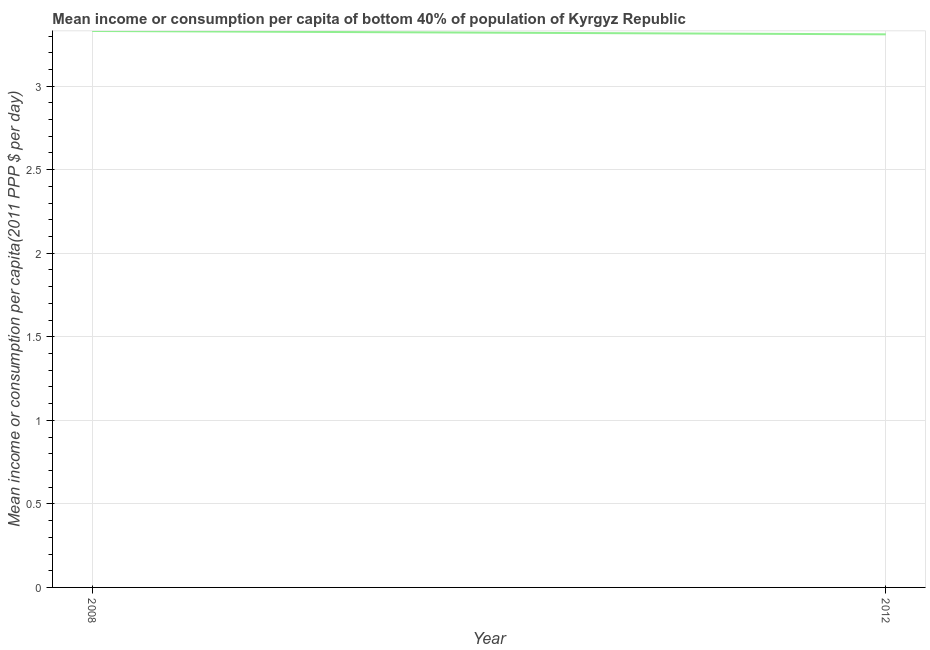What is the mean income or consumption in 2012?
Your answer should be very brief. 3.31. Across all years, what is the maximum mean income or consumption?
Give a very brief answer. 3.33. Across all years, what is the minimum mean income or consumption?
Offer a terse response. 3.31. In which year was the mean income or consumption maximum?
Provide a succinct answer. 2008. What is the sum of the mean income or consumption?
Keep it short and to the point. 6.64. What is the difference between the mean income or consumption in 2008 and 2012?
Give a very brief answer. 0.02. What is the average mean income or consumption per year?
Your answer should be very brief. 3.32. What is the median mean income or consumption?
Provide a succinct answer. 3.32. In how many years, is the mean income or consumption greater than 2.1 $?
Keep it short and to the point. 2. What is the ratio of the mean income or consumption in 2008 to that in 2012?
Keep it short and to the point. 1.01. Is the mean income or consumption in 2008 less than that in 2012?
Your answer should be compact. No. In how many years, is the mean income or consumption greater than the average mean income or consumption taken over all years?
Provide a short and direct response. 1. Does the mean income or consumption monotonically increase over the years?
Your answer should be compact. No. How many lines are there?
Your answer should be very brief. 1. What is the difference between two consecutive major ticks on the Y-axis?
Keep it short and to the point. 0.5. Does the graph contain grids?
Make the answer very short. Yes. What is the title of the graph?
Give a very brief answer. Mean income or consumption per capita of bottom 40% of population of Kyrgyz Republic. What is the label or title of the Y-axis?
Provide a succinct answer. Mean income or consumption per capita(2011 PPP $ per day). What is the Mean income or consumption per capita(2011 PPP $ per day) in 2008?
Provide a succinct answer. 3.33. What is the Mean income or consumption per capita(2011 PPP $ per day) in 2012?
Provide a succinct answer. 3.31. What is the ratio of the Mean income or consumption per capita(2011 PPP $ per day) in 2008 to that in 2012?
Offer a very short reply. 1.01. 